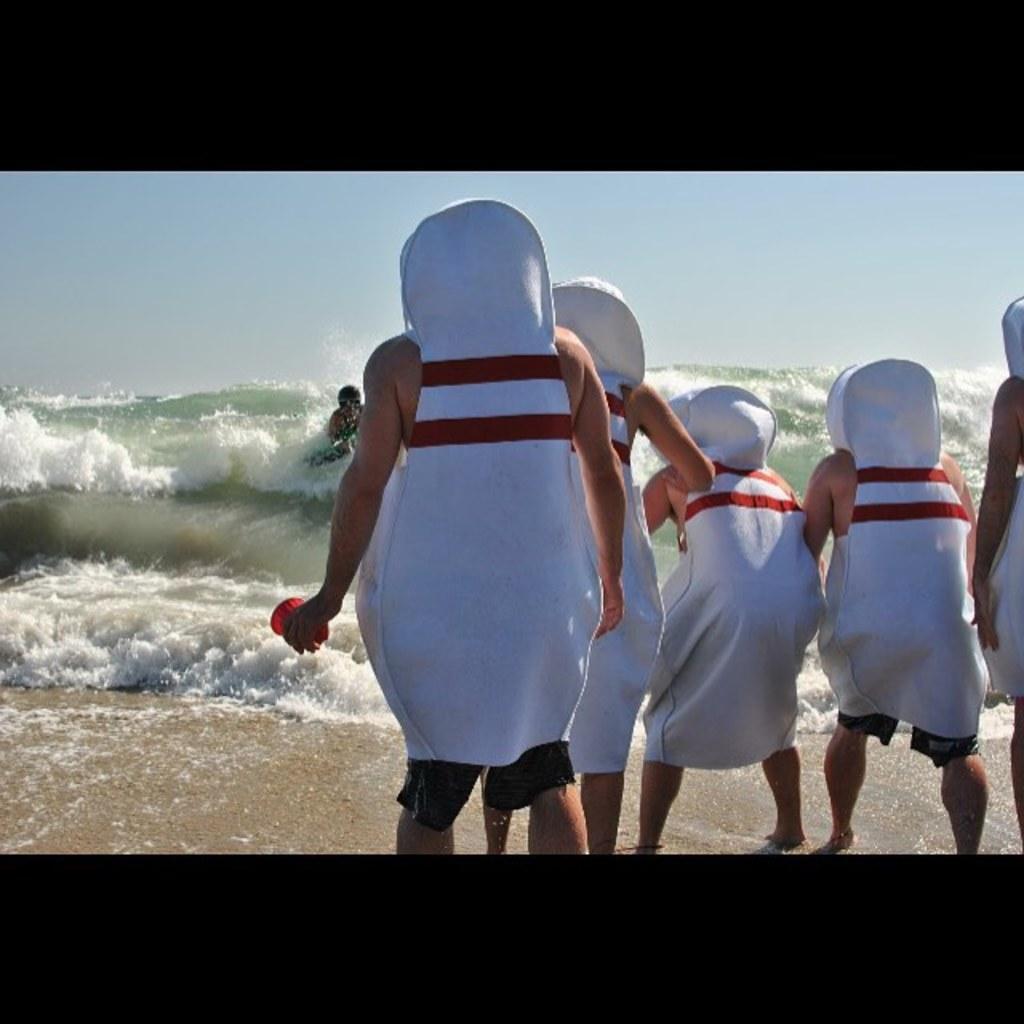Please provide a concise description of this image. In this image we can see people in the same costume and we can also see water and sky. 